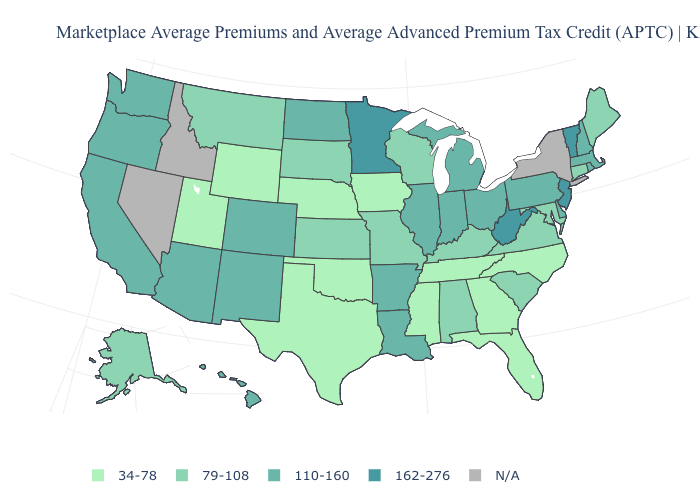Does the map have missing data?
Give a very brief answer. Yes. What is the highest value in the USA?
Write a very short answer. 162-276. Name the states that have a value in the range 79-108?
Short answer required. Alabama, Alaska, Connecticut, Kansas, Kentucky, Maine, Maryland, Missouri, Montana, South Carolina, South Dakota, Virginia, Wisconsin. Does Missouri have the lowest value in the MidWest?
Answer briefly. No. Name the states that have a value in the range N/A?
Answer briefly. Idaho, Nevada, New York. Name the states that have a value in the range 34-78?
Quick response, please. Florida, Georgia, Iowa, Mississippi, Nebraska, North Carolina, Oklahoma, Tennessee, Texas, Utah, Wyoming. Does Wyoming have the lowest value in the West?
Write a very short answer. Yes. Among the states that border South Dakota , which have the lowest value?
Answer briefly. Iowa, Nebraska, Wyoming. Among the states that border Kansas , does Colorado have the highest value?
Write a very short answer. Yes. Does the map have missing data?
Be succinct. Yes. Which states have the lowest value in the West?
Quick response, please. Utah, Wyoming. Name the states that have a value in the range 110-160?
Quick response, please. Arizona, Arkansas, California, Colorado, Delaware, Hawaii, Illinois, Indiana, Louisiana, Massachusetts, Michigan, New Hampshire, New Mexico, North Dakota, Ohio, Oregon, Pennsylvania, Rhode Island, Washington. Does Connecticut have the highest value in the Northeast?
Give a very brief answer. No. What is the value of Idaho?
Answer briefly. N/A. 